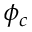<formula> <loc_0><loc_0><loc_500><loc_500>\phi _ { c }</formula> 